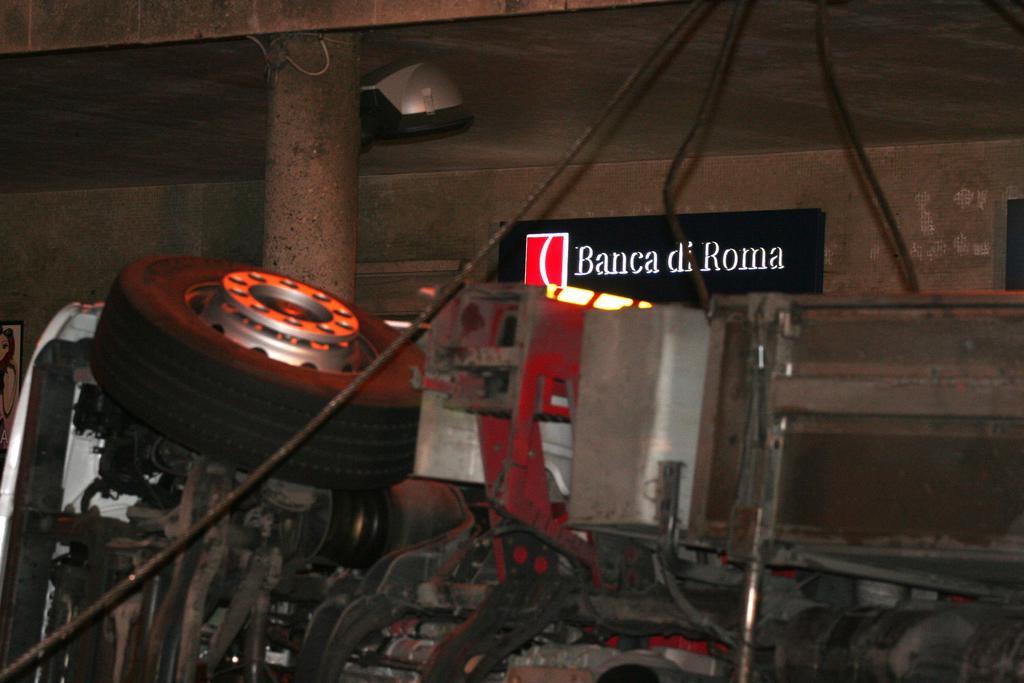In one or two sentences, can you explain what this image depicts? In the picture there is a machine, on the left side there is a wheel and behind the machine there is a wall and there is some name plate attached to that wall. 